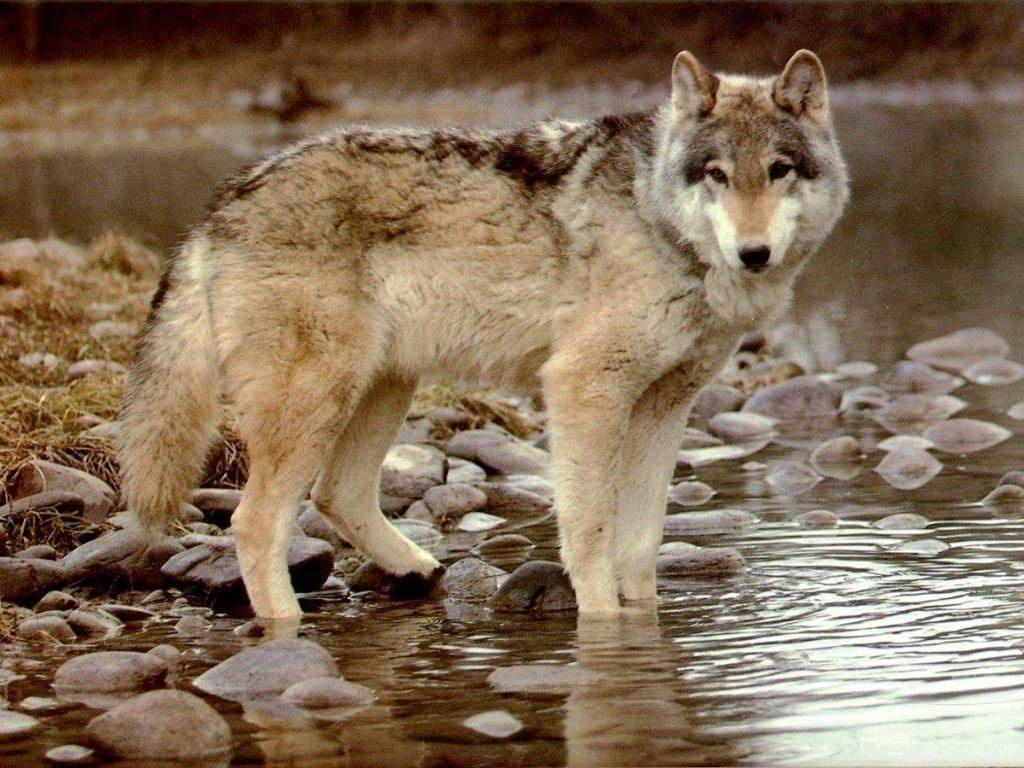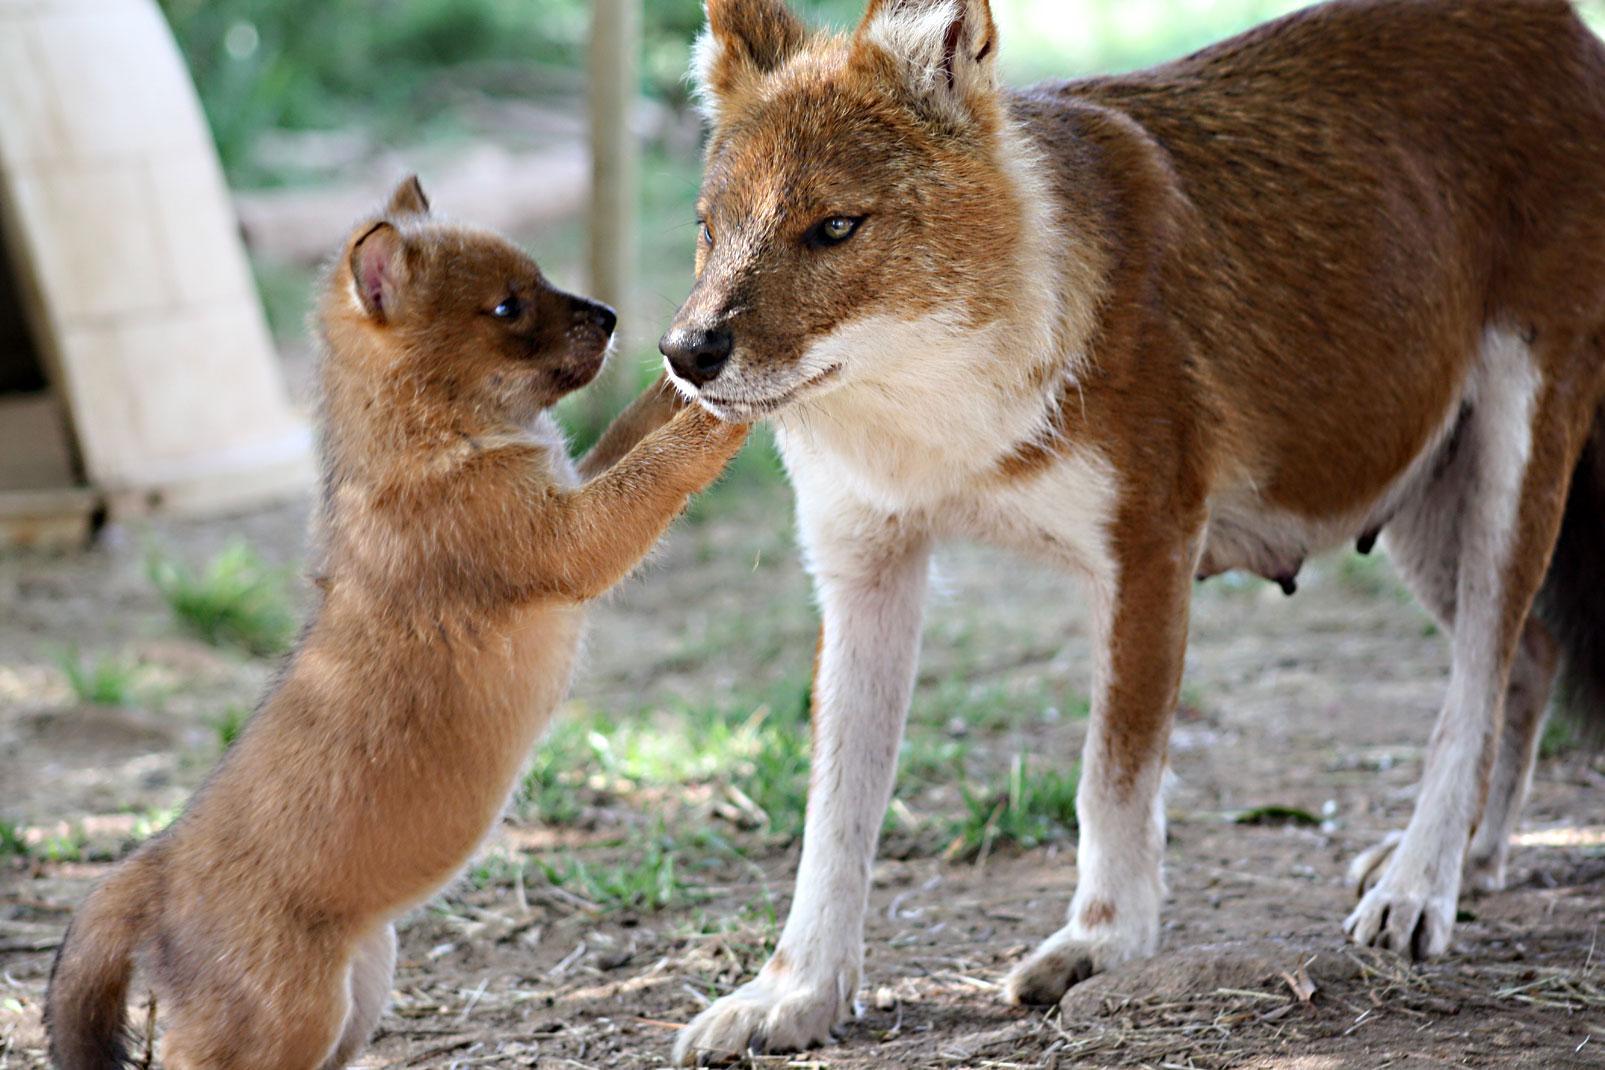The first image is the image on the left, the second image is the image on the right. Examine the images to the left and right. Is the description "There are two animals in the image on the right." accurate? Answer yes or no. Yes. 